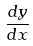<formula> <loc_0><loc_0><loc_500><loc_500>\frac { d y } { d x }</formula> 